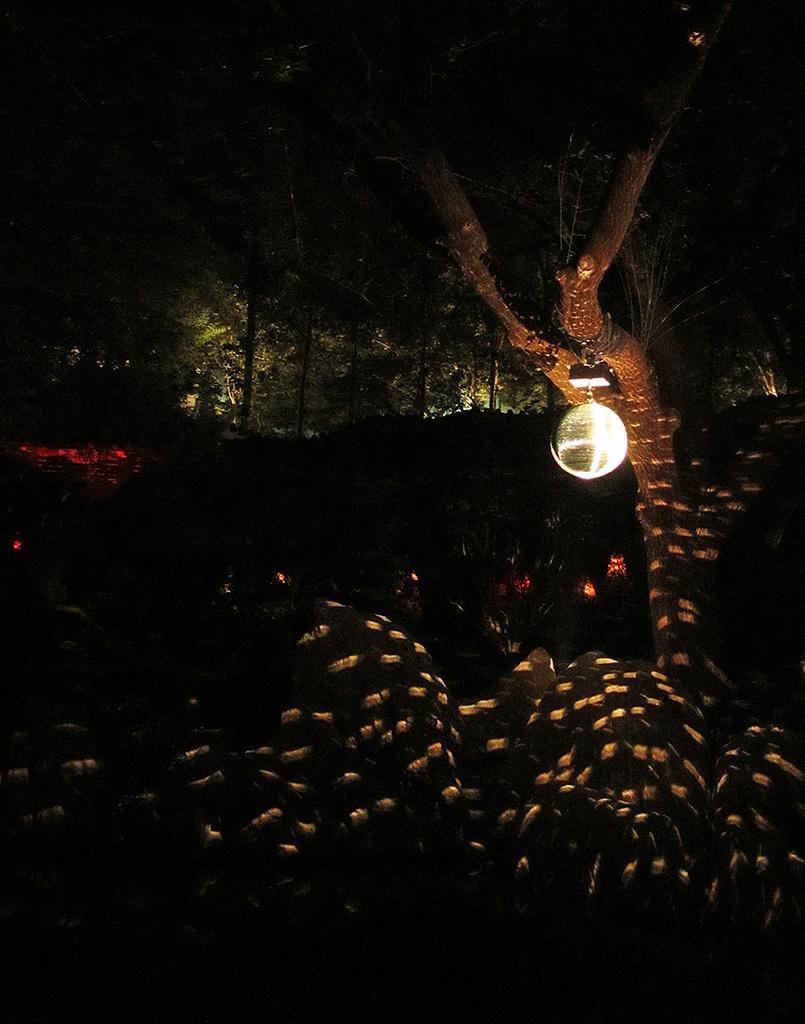Can you describe this image briefly? In this picture we can see some group of trees and light attached to the tree. 